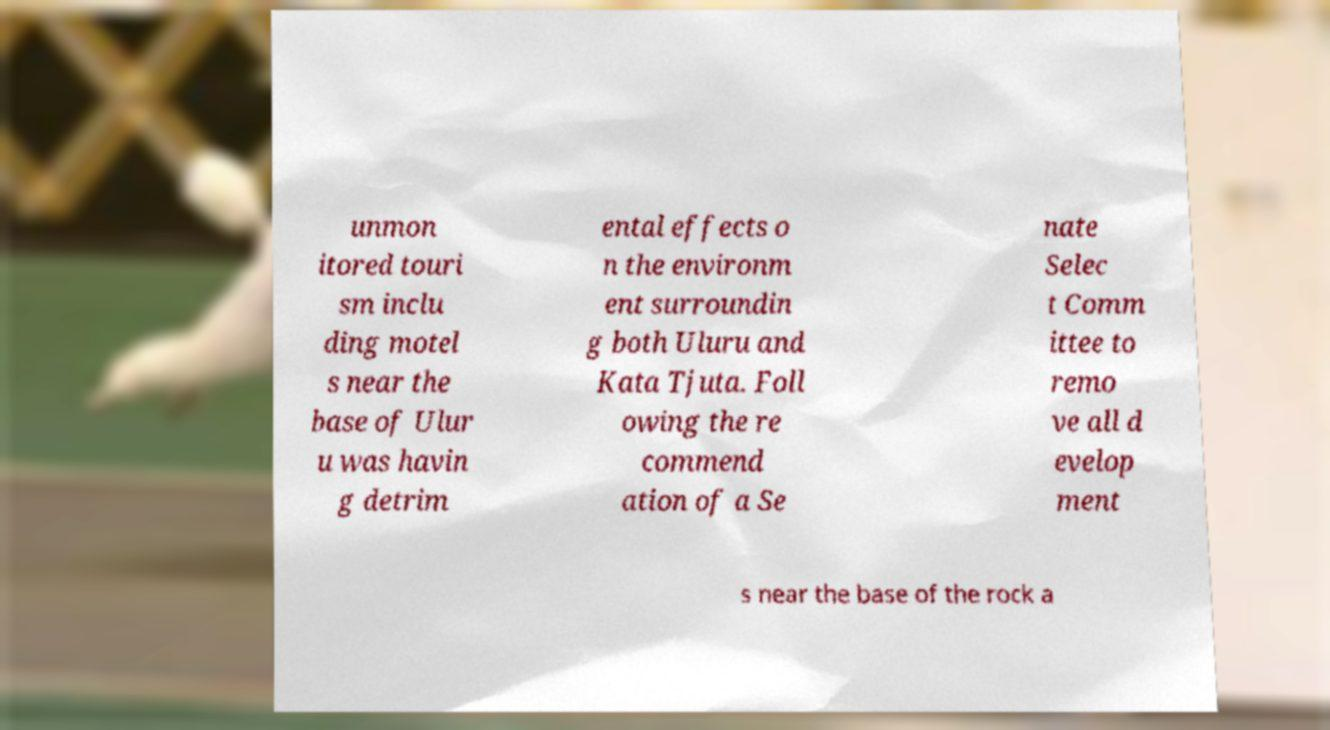Could you assist in decoding the text presented in this image and type it out clearly? unmon itored touri sm inclu ding motel s near the base of Ulur u was havin g detrim ental effects o n the environm ent surroundin g both Uluru and Kata Tjuta. Foll owing the re commend ation of a Se nate Selec t Comm ittee to remo ve all d evelop ment s near the base of the rock a 